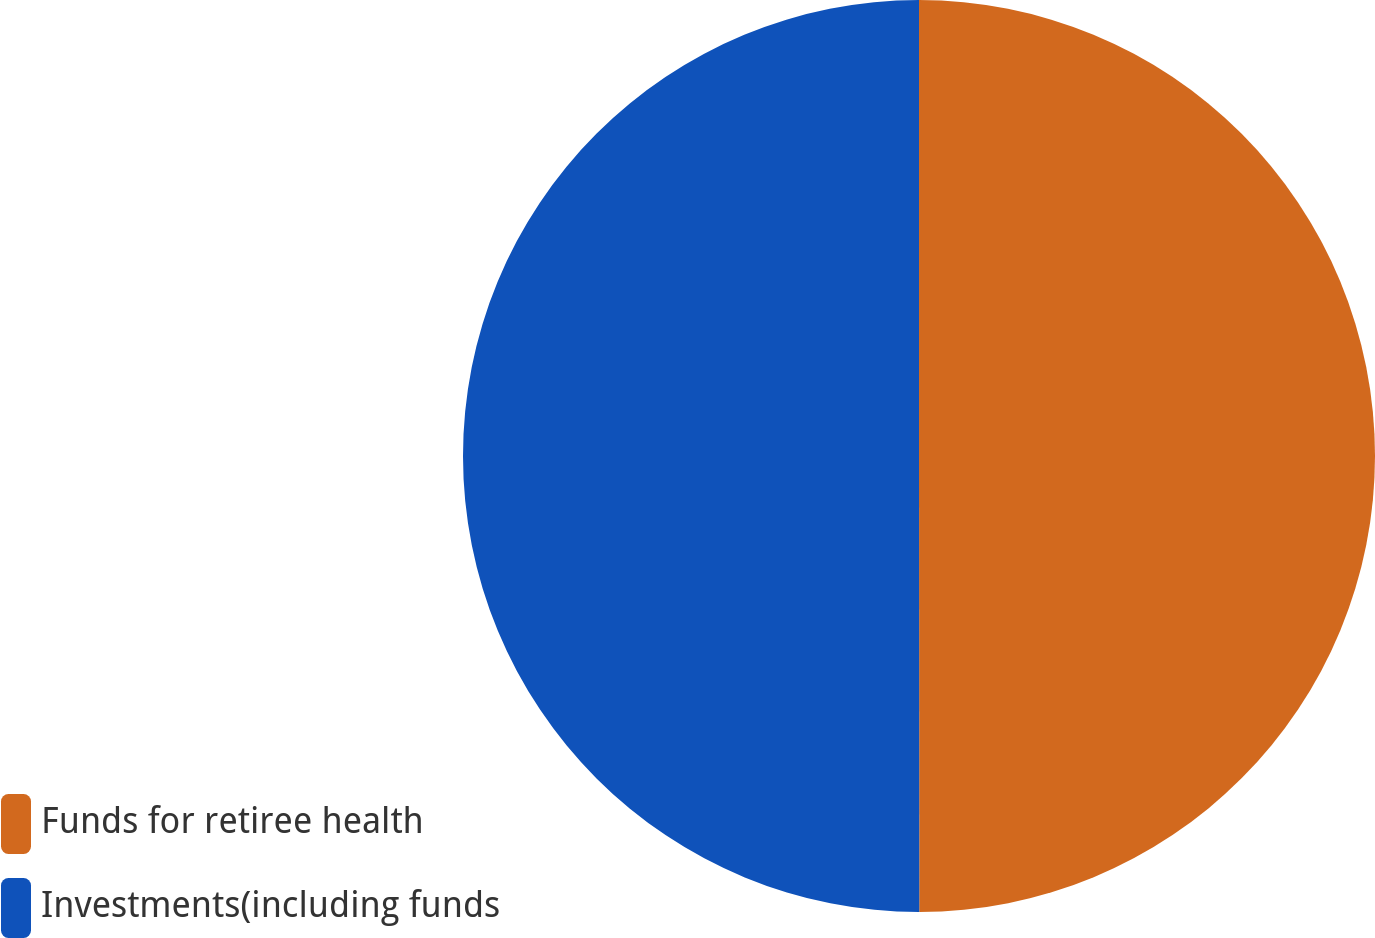<chart> <loc_0><loc_0><loc_500><loc_500><pie_chart><fcel>Funds for retiree health<fcel>Investments(including funds<nl><fcel>49.99%<fcel>50.01%<nl></chart> 